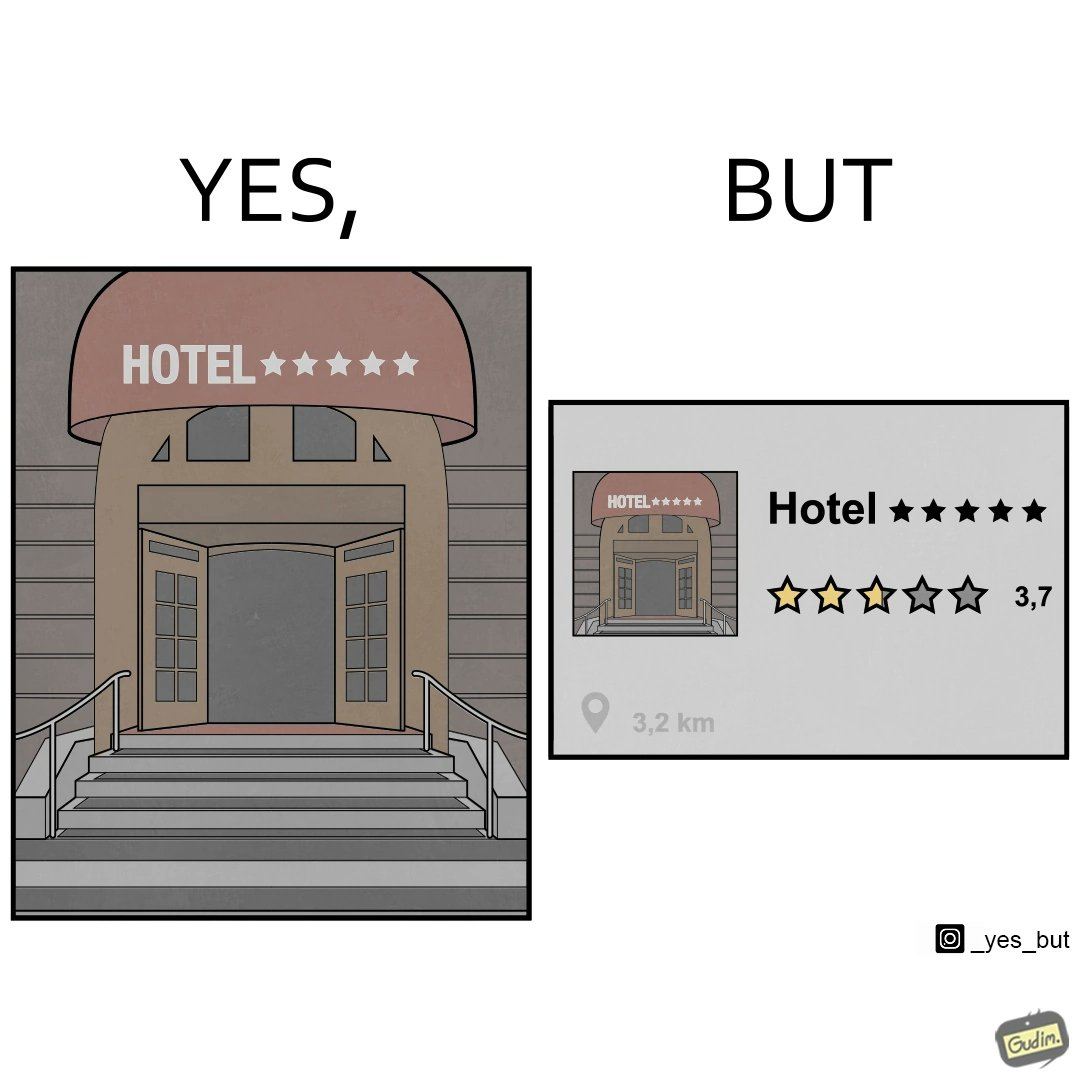Describe the contrast between the left and right parts of this image. In the left part of the image: The image shows the front gate of a hotel. The name of the hotel is "HOTEL 5 Stars" but the instead of the words 5 stars, five stars are next to the word "HOTEL" In the right part of the image: The image shows a rating of 3.7 out of 5 to a hotel name hotel 5 stars. 